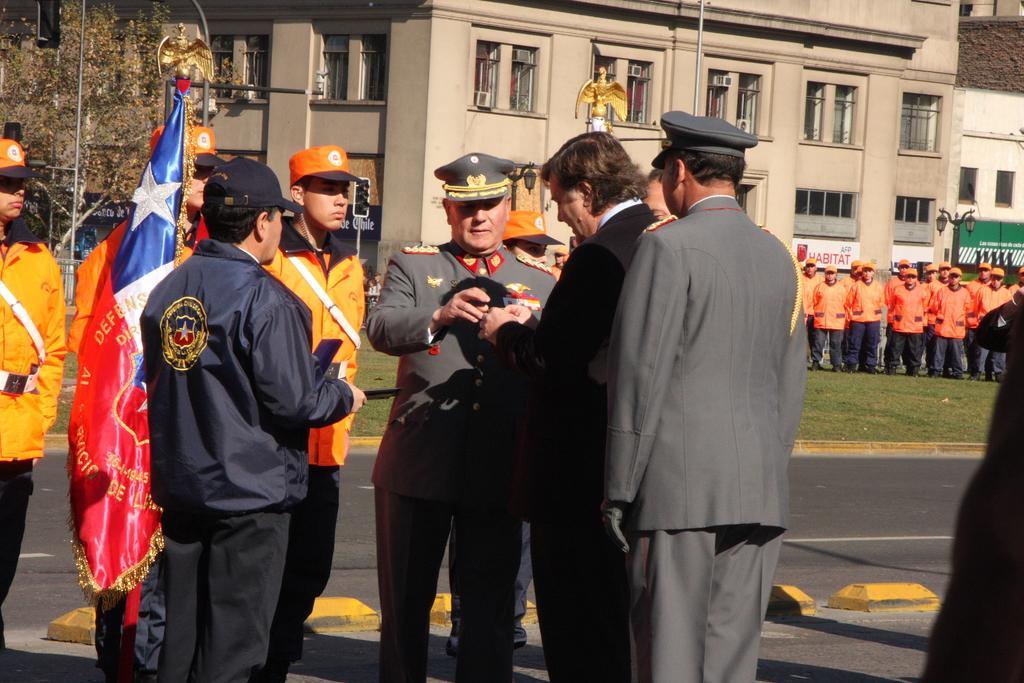In one or two sentences, can you explain what this image depicts? In this picture I can see there are a group of people standing and they are wearing a blazers and in the backdrop I can see there are some other people standing in the backdrop they are wearing a orange shirt and a black pant. 